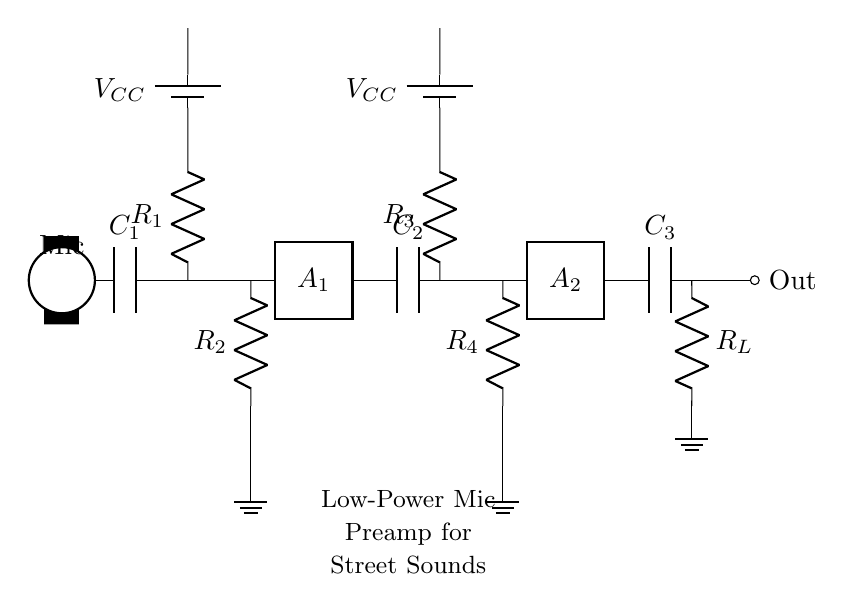What type of component is C1? C1 is a coupling capacitor, which is used to block DC voltage while allowing AC signals, such as audio, to pass through.
Answer: coupling capacitor What is the purpose of R_L in this circuit? R_L is the load resistor, which is used to match the output impedance of the amplifier and allows the output signal to be delivered to the next stage or device.
Answer: load resistor How many amplification stages are present in this circuit? There are two amplification stages, represented by A1 and A2, which enhance the signal from the microphone through a series of components.
Answer: two What is the value of the first resistor, R1? R1 is the first stage resistor, and its value can be inferred from the circuit design which often determines the gain and bandwidth of the amplifier stage. However, an exact numeric value is not provided in the circuit.
Answer: not specified What is the function of C2 in this circuit? C2 serves as an interstage coupling capacitor, which blocks DC while allowing the amplified AC signal to pass from the first to the second amplification stage.
Answer: interstage coupling capacitor Which voltage supply is used for both amplifier stages? The voltage supply for both amplifier stages is the same, denoted as V_CC, which provides the necessary power for operation.
Answer: V_CC Does this circuit include a ground reference? Yes, there are multiple ground references indicated in the circuit at various points for proper operation and stability.
Answer: yes 